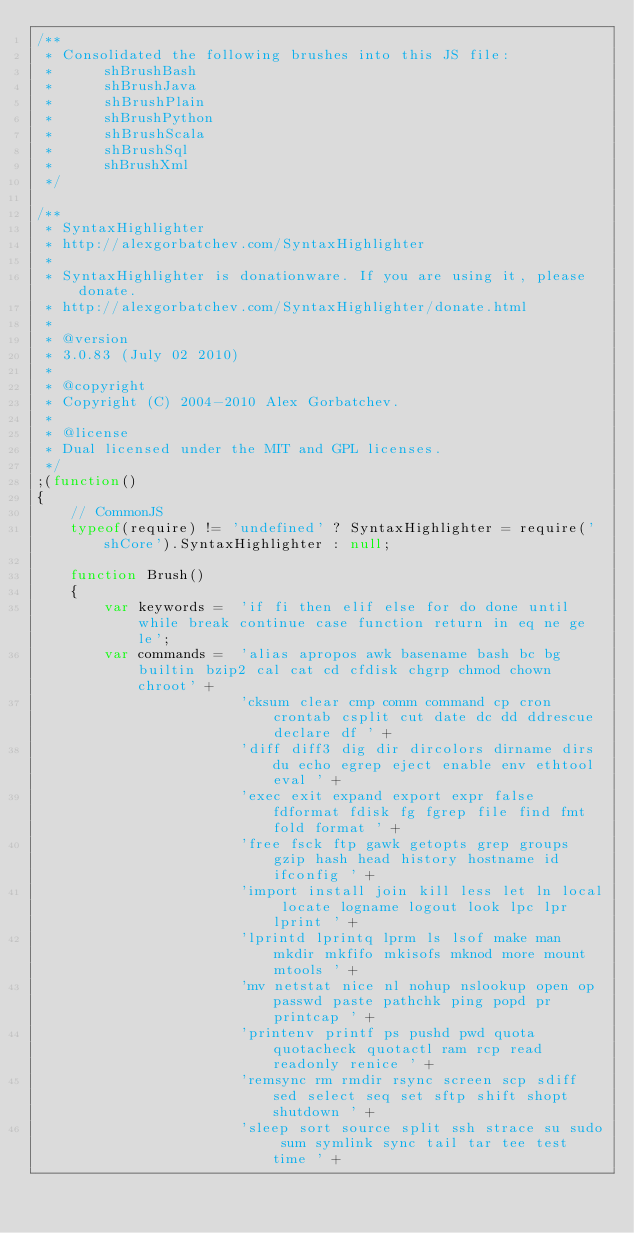Convert code to text. <code><loc_0><loc_0><loc_500><loc_500><_JavaScript_>/** 
 * Consolidated the following brushes into this JS file:
 * 		shBrushBash
 *		shBrushJava
 *		shBrushPlain
 *		shBrushPython
 *		shBrushScala
 *		shBrushSql
 *		shBrushXml
 */

/**
 * SyntaxHighlighter
 * http://alexgorbatchev.com/SyntaxHighlighter
 *
 * SyntaxHighlighter is donationware. If you are using it, please donate.
 * http://alexgorbatchev.com/SyntaxHighlighter/donate.html
 *
 * @version
 * 3.0.83 (July 02 2010)
 * 
 * @copyright
 * Copyright (C) 2004-2010 Alex Gorbatchev.
 *
 * @license
 * Dual licensed under the MIT and GPL licenses.
 */
;(function()
{
	// CommonJS
	typeof(require) != 'undefined' ? SyntaxHighlighter = require('shCore').SyntaxHighlighter : null;

	function Brush()
	{
		var keywords =	'if fi then elif else for do done until while break continue case function return in eq ne ge le';
		var commands =  'alias apropos awk basename bash bc bg builtin bzip2 cal cat cd cfdisk chgrp chmod chown chroot' +
						'cksum clear cmp comm command cp cron crontab csplit cut date dc dd ddrescue declare df ' +
						'diff diff3 dig dir dircolors dirname dirs du echo egrep eject enable env ethtool eval ' +
						'exec exit expand export expr false fdformat fdisk fg fgrep file find fmt fold format ' +
						'free fsck ftp gawk getopts grep groups gzip hash head history hostname id ifconfig ' +
						'import install join kill less let ln local locate logname logout look lpc lpr lprint ' +
						'lprintd lprintq lprm ls lsof make man mkdir mkfifo mkisofs mknod more mount mtools ' +
						'mv netstat nice nl nohup nslookup open op passwd paste pathchk ping popd pr printcap ' +
						'printenv printf ps pushd pwd quota quotacheck quotactl ram rcp read readonly renice ' +
						'remsync rm rmdir rsync screen scp sdiff sed select seq set sftp shift shopt shutdown ' +
						'sleep sort source split ssh strace su sudo sum symlink sync tail tar tee test time ' +</code> 